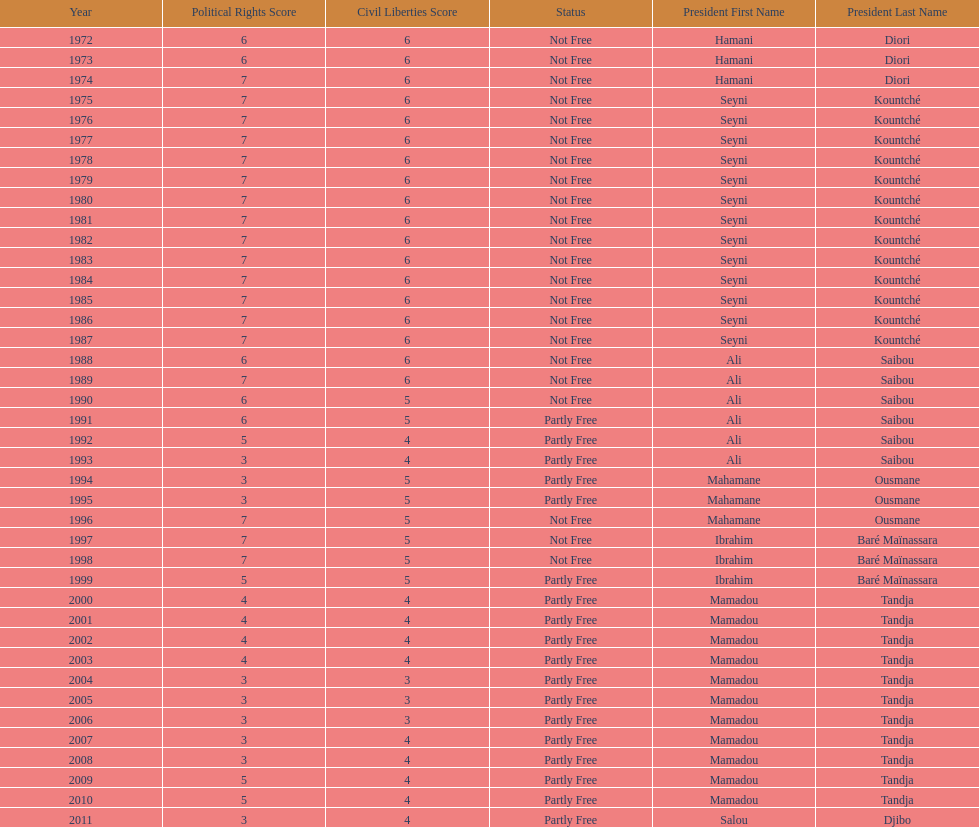Who ruled longer, ali saibou or mamadou tandja? Mamadou Tandja. 